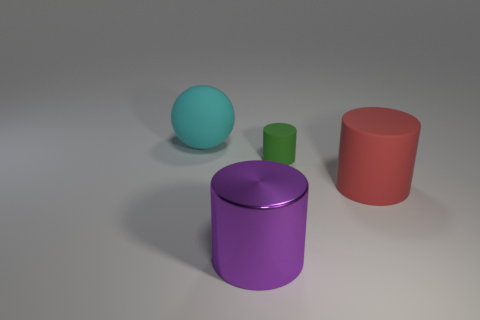Subtract all purple shiny cylinders. How many cylinders are left? 2 Add 3 big gray things. How many objects exist? 7 Subtract all green cylinders. How many cylinders are left? 2 Subtract all balls. How many objects are left? 3 Subtract all purple metal things. Subtract all big purple cylinders. How many objects are left? 2 Add 1 cyan objects. How many cyan objects are left? 2 Add 3 large red cylinders. How many large red cylinders exist? 4 Subtract 1 green cylinders. How many objects are left? 3 Subtract all purple cylinders. Subtract all gray balls. How many cylinders are left? 2 